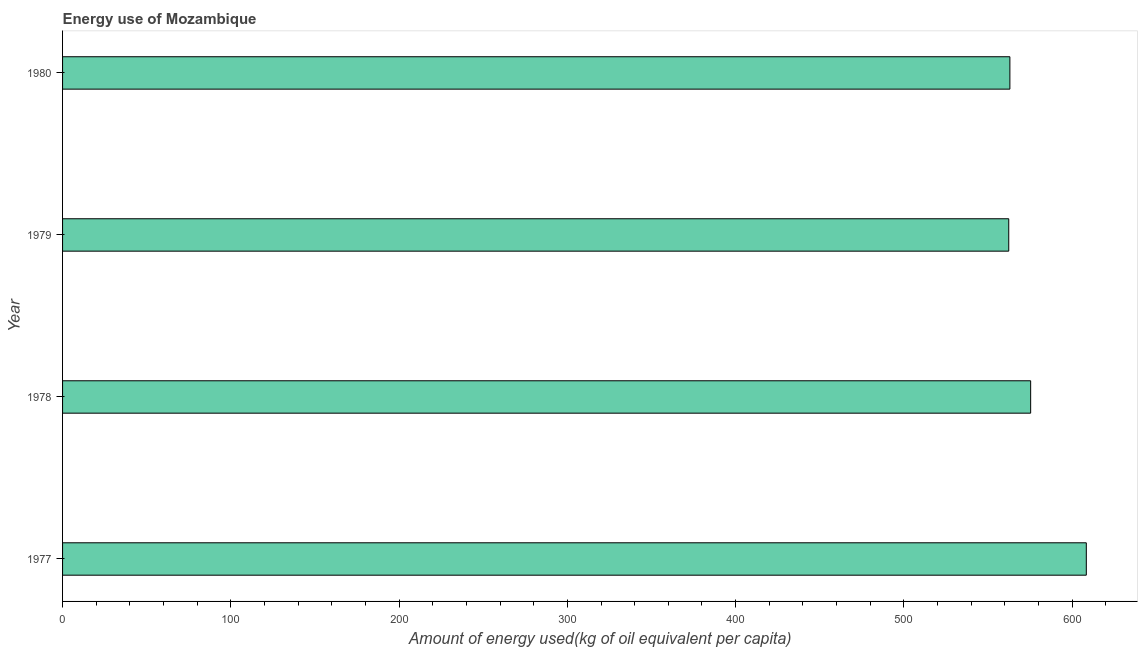What is the title of the graph?
Offer a very short reply. Energy use of Mozambique. What is the label or title of the X-axis?
Make the answer very short. Amount of energy used(kg of oil equivalent per capita). What is the amount of energy used in 1978?
Keep it short and to the point. 575.34. Across all years, what is the maximum amount of energy used?
Ensure brevity in your answer.  608.41. Across all years, what is the minimum amount of energy used?
Provide a short and direct response. 562.32. In which year was the amount of energy used maximum?
Provide a short and direct response. 1977. In which year was the amount of energy used minimum?
Your answer should be compact. 1979. What is the sum of the amount of energy used?
Offer a very short reply. 2309.05. What is the difference between the amount of energy used in 1977 and 1980?
Provide a short and direct response. 45.41. What is the average amount of energy used per year?
Provide a succinct answer. 577.26. What is the median amount of energy used?
Provide a succinct answer. 569.16. Is the amount of energy used in 1978 less than that in 1979?
Offer a terse response. No. Is the difference between the amount of energy used in 1978 and 1979 greater than the difference between any two years?
Offer a very short reply. No. What is the difference between the highest and the second highest amount of energy used?
Give a very brief answer. 33.07. What is the difference between the highest and the lowest amount of energy used?
Offer a terse response. 46.09. How many years are there in the graph?
Provide a short and direct response. 4. Are the values on the major ticks of X-axis written in scientific E-notation?
Provide a succinct answer. No. What is the Amount of energy used(kg of oil equivalent per capita) in 1977?
Give a very brief answer. 608.41. What is the Amount of energy used(kg of oil equivalent per capita) in 1978?
Make the answer very short. 575.34. What is the Amount of energy used(kg of oil equivalent per capita) of 1979?
Give a very brief answer. 562.32. What is the Amount of energy used(kg of oil equivalent per capita) of 1980?
Provide a short and direct response. 562.99. What is the difference between the Amount of energy used(kg of oil equivalent per capita) in 1977 and 1978?
Your answer should be very brief. 33.07. What is the difference between the Amount of energy used(kg of oil equivalent per capita) in 1977 and 1979?
Provide a succinct answer. 46.09. What is the difference between the Amount of energy used(kg of oil equivalent per capita) in 1977 and 1980?
Your answer should be compact. 45.42. What is the difference between the Amount of energy used(kg of oil equivalent per capita) in 1978 and 1979?
Provide a succinct answer. 13.02. What is the difference between the Amount of energy used(kg of oil equivalent per capita) in 1978 and 1980?
Keep it short and to the point. 12.35. What is the difference between the Amount of energy used(kg of oil equivalent per capita) in 1979 and 1980?
Keep it short and to the point. -0.67. What is the ratio of the Amount of energy used(kg of oil equivalent per capita) in 1977 to that in 1978?
Keep it short and to the point. 1.06. What is the ratio of the Amount of energy used(kg of oil equivalent per capita) in 1977 to that in 1979?
Provide a succinct answer. 1.08. What is the ratio of the Amount of energy used(kg of oil equivalent per capita) in 1977 to that in 1980?
Give a very brief answer. 1.08. What is the ratio of the Amount of energy used(kg of oil equivalent per capita) in 1978 to that in 1979?
Keep it short and to the point. 1.02. What is the ratio of the Amount of energy used(kg of oil equivalent per capita) in 1978 to that in 1980?
Ensure brevity in your answer.  1.02. What is the ratio of the Amount of energy used(kg of oil equivalent per capita) in 1979 to that in 1980?
Your response must be concise. 1. 